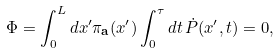Convert formula to latex. <formula><loc_0><loc_0><loc_500><loc_500>\Phi = \int _ { 0 } ^ { L } d x ^ { \prime } \pi _ { \mathbf a } ( x ^ { \prime } ) \int _ { 0 } ^ { \tau } d t \, \dot { P } ( x ^ { \prime } , t ) = 0 ,</formula> 